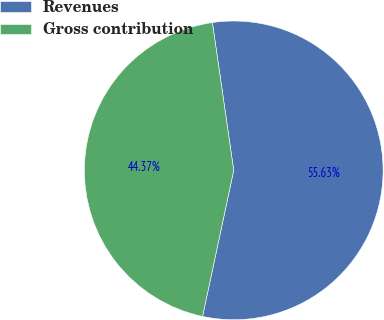Convert chart. <chart><loc_0><loc_0><loc_500><loc_500><pie_chart><fcel>Revenues<fcel>Gross contribution<nl><fcel>55.63%<fcel>44.37%<nl></chart> 